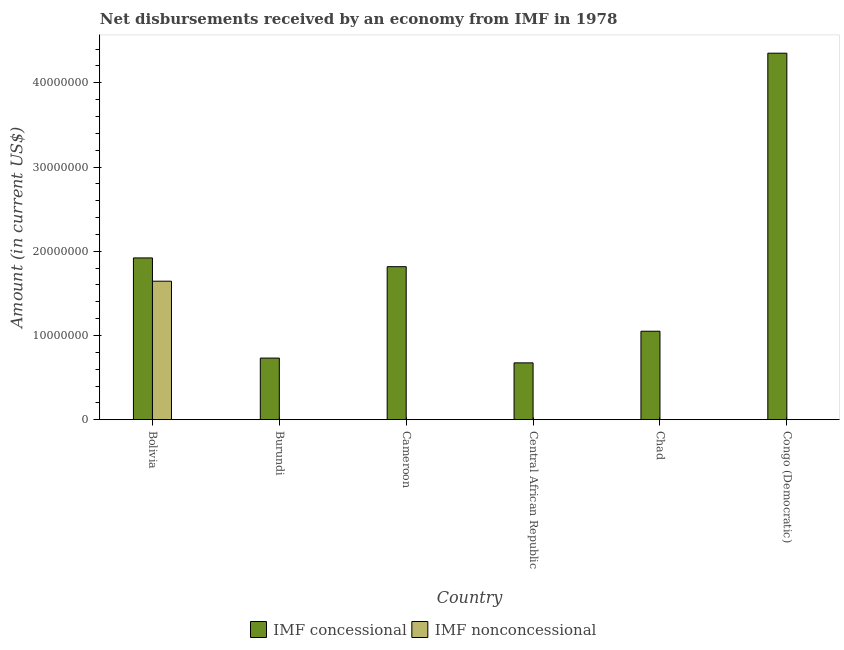Are the number of bars per tick equal to the number of legend labels?
Make the answer very short. No. How many bars are there on the 2nd tick from the left?
Ensure brevity in your answer.  1. How many bars are there on the 3rd tick from the right?
Your answer should be very brief. 1. What is the net concessional disbursements from imf in Bolivia?
Ensure brevity in your answer.  1.92e+07. Across all countries, what is the maximum net non concessional disbursements from imf?
Your response must be concise. 1.64e+07. In which country was the net concessional disbursements from imf maximum?
Ensure brevity in your answer.  Congo (Democratic). What is the total net non concessional disbursements from imf in the graph?
Ensure brevity in your answer.  1.64e+07. What is the difference between the net concessional disbursements from imf in Central African Republic and that in Chad?
Offer a very short reply. -3.76e+06. What is the difference between the net concessional disbursements from imf in Chad and the net non concessional disbursements from imf in Central African Republic?
Give a very brief answer. 1.05e+07. What is the average net concessional disbursements from imf per country?
Provide a short and direct response. 1.76e+07. What is the difference between the net concessional disbursements from imf and net non concessional disbursements from imf in Bolivia?
Your response must be concise. 2.76e+06. In how many countries, is the net non concessional disbursements from imf greater than 24000000 US$?
Your response must be concise. 0. What is the ratio of the net concessional disbursements from imf in Bolivia to that in Cameroon?
Provide a short and direct response. 1.06. Is the net concessional disbursements from imf in Burundi less than that in Chad?
Give a very brief answer. Yes. What is the difference between the highest and the second highest net concessional disbursements from imf?
Keep it short and to the point. 2.43e+07. What is the difference between the highest and the lowest net concessional disbursements from imf?
Your response must be concise. 3.68e+07. In how many countries, is the net concessional disbursements from imf greater than the average net concessional disbursements from imf taken over all countries?
Your response must be concise. 3. Is the sum of the net concessional disbursements from imf in Chad and Congo (Democratic) greater than the maximum net non concessional disbursements from imf across all countries?
Provide a short and direct response. Yes. Are all the bars in the graph horizontal?
Give a very brief answer. No. How many countries are there in the graph?
Make the answer very short. 6. What is the difference between two consecutive major ticks on the Y-axis?
Keep it short and to the point. 1.00e+07. Where does the legend appear in the graph?
Your answer should be compact. Bottom center. What is the title of the graph?
Provide a succinct answer. Net disbursements received by an economy from IMF in 1978. What is the label or title of the Y-axis?
Your response must be concise. Amount (in current US$). What is the Amount (in current US$) in IMF concessional in Bolivia?
Provide a short and direct response. 1.92e+07. What is the Amount (in current US$) of IMF nonconcessional in Bolivia?
Provide a succinct answer. 1.64e+07. What is the Amount (in current US$) in IMF concessional in Burundi?
Your answer should be very brief. 7.32e+06. What is the Amount (in current US$) of IMF nonconcessional in Burundi?
Your answer should be very brief. 0. What is the Amount (in current US$) in IMF concessional in Cameroon?
Offer a very short reply. 1.82e+07. What is the Amount (in current US$) in IMF concessional in Central African Republic?
Your answer should be compact. 6.75e+06. What is the Amount (in current US$) of IMF concessional in Chad?
Your response must be concise. 1.05e+07. What is the Amount (in current US$) of IMF concessional in Congo (Democratic)?
Provide a succinct answer. 4.35e+07. What is the Amount (in current US$) in IMF nonconcessional in Congo (Democratic)?
Give a very brief answer. 0. Across all countries, what is the maximum Amount (in current US$) in IMF concessional?
Offer a terse response. 4.35e+07. Across all countries, what is the maximum Amount (in current US$) of IMF nonconcessional?
Offer a very short reply. 1.64e+07. Across all countries, what is the minimum Amount (in current US$) of IMF concessional?
Provide a short and direct response. 6.75e+06. What is the total Amount (in current US$) in IMF concessional in the graph?
Provide a succinct answer. 1.05e+08. What is the total Amount (in current US$) in IMF nonconcessional in the graph?
Provide a succinct answer. 1.64e+07. What is the difference between the Amount (in current US$) of IMF concessional in Bolivia and that in Burundi?
Make the answer very short. 1.19e+07. What is the difference between the Amount (in current US$) in IMF concessional in Bolivia and that in Cameroon?
Give a very brief answer. 1.04e+06. What is the difference between the Amount (in current US$) of IMF concessional in Bolivia and that in Central African Republic?
Provide a succinct answer. 1.25e+07. What is the difference between the Amount (in current US$) of IMF concessional in Bolivia and that in Chad?
Ensure brevity in your answer.  8.70e+06. What is the difference between the Amount (in current US$) in IMF concessional in Bolivia and that in Congo (Democratic)?
Keep it short and to the point. -2.43e+07. What is the difference between the Amount (in current US$) in IMF concessional in Burundi and that in Cameroon?
Offer a very short reply. -1.09e+07. What is the difference between the Amount (in current US$) of IMF concessional in Burundi and that in Central African Republic?
Make the answer very short. 5.68e+05. What is the difference between the Amount (in current US$) in IMF concessional in Burundi and that in Chad?
Offer a very short reply. -3.19e+06. What is the difference between the Amount (in current US$) in IMF concessional in Burundi and that in Congo (Democratic)?
Offer a very short reply. -3.62e+07. What is the difference between the Amount (in current US$) in IMF concessional in Cameroon and that in Central African Republic?
Give a very brief answer. 1.14e+07. What is the difference between the Amount (in current US$) of IMF concessional in Cameroon and that in Chad?
Offer a very short reply. 7.66e+06. What is the difference between the Amount (in current US$) in IMF concessional in Cameroon and that in Congo (Democratic)?
Make the answer very short. -2.53e+07. What is the difference between the Amount (in current US$) of IMF concessional in Central African Republic and that in Chad?
Ensure brevity in your answer.  -3.76e+06. What is the difference between the Amount (in current US$) in IMF concessional in Central African Republic and that in Congo (Democratic)?
Provide a short and direct response. -3.68e+07. What is the difference between the Amount (in current US$) of IMF concessional in Chad and that in Congo (Democratic)?
Make the answer very short. -3.30e+07. What is the average Amount (in current US$) of IMF concessional per country?
Give a very brief answer. 1.76e+07. What is the average Amount (in current US$) of IMF nonconcessional per country?
Make the answer very short. 2.74e+06. What is the difference between the Amount (in current US$) of IMF concessional and Amount (in current US$) of IMF nonconcessional in Bolivia?
Make the answer very short. 2.76e+06. What is the ratio of the Amount (in current US$) of IMF concessional in Bolivia to that in Burundi?
Your answer should be very brief. 2.63. What is the ratio of the Amount (in current US$) in IMF concessional in Bolivia to that in Cameroon?
Keep it short and to the point. 1.06. What is the ratio of the Amount (in current US$) of IMF concessional in Bolivia to that in Central African Republic?
Offer a very short reply. 2.85. What is the ratio of the Amount (in current US$) in IMF concessional in Bolivia to that in Chad?
Your answer should be compact. 1.83. What is the ratio of the Amount (in current US$) in IMF concessional in Bolivia to that in Congo (Democratic)?
Give a very brief answer. 0.44. What is the ratio of the Amount (in current US$) of IMF concessional in Burundi to that in Cameroon?
Provide a short and direct response. 0.4. What is the ratio of the Amount (in current US$) in IMF concessional in Burundi to that in Central African Republic?
Give a very brief answer. 1.08. What is the ratio of the Amount (in current US$) of IMF concessional in Burundi to that in Chad?
Provide a short and direct response. 0.7. What is the ratio of the Amount (in current US$) of IMF concessional in Burundi to that in Congo (Democratic)?
Your answer should be compact. 0.17. What is the ratio of the Amount (in current US$) in IMF concessional in Cameroon to that in Central African Republic?
Offer a very short reply. 2.69. What is the ratio of the Amount (in current US$) in IMF concessional in Cameroon to that in Chad?
Your answer should be compact. 1.73. What is the ratio of the Amount (in current US$) in IMF concessional in Cameroon to that in Congo (Democratic)?
Offer a very short reply. 0.42. What is the ratio of the Amount (in current US$) in IMF concessional in Central African Republic to that in Chad?
Offer a terse response. 0.64. What is the ratio of the Amount (in current US$) of IMF concessional in Central African Republic to that in Congo (Democratic)?
Your answer should be very brief. 0.16. What is the ratio of the Amount (in current US$) of IMF concessional in Chad to that in Congo (Democratic)?
Provide a short and direct response. 0.24. What is the difference between the highest and the second highest Amount (in current US$) in IMF concessional?
Provide a succinct answer. 2.43e+07. What is the difference between the highest and the lowest Amount (in current US$) in IMF concessional?
Your answer should be compact. 3.68e+07. What is the difference between the highest and the lowest Amount (in current US$) of IMF nonconcessional?
Your answer should be compact. 1.64e+07. 